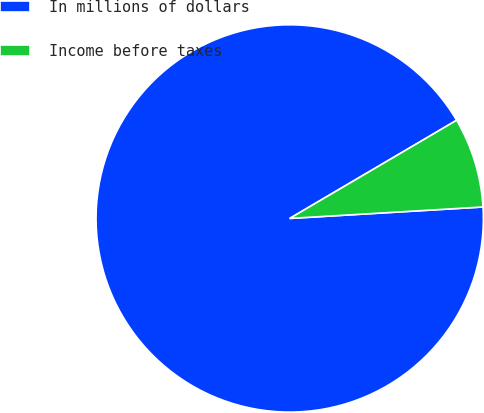Convert chart. <chart><loc_0><loc_0><loc_500><loc_500><pie_chart><fcel>In millions of dollars<fcel>Income before taxes<nl><fcel>92.48%<fcel>7.52%<nl></chart> 